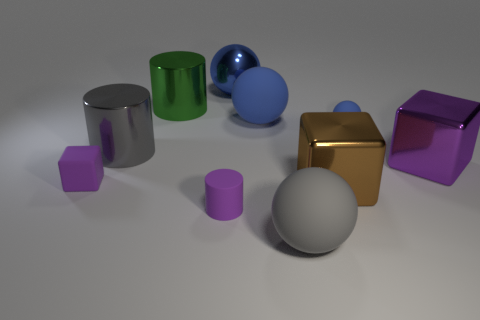Subtract all purple metal blocks. How many blocks are left? 2 Subtract all brown blocks. How many blue balls are left? 3 Subtract all gray spheres. How many spheres are left? 3 Subtract all cubes. How many objects are left? 7 Add 6 yellow cylinders. How many yellow cylinders exist? 6 Subtract 0 cyan blocks. How many objects are left? 10 Subtract all yellow spheres. Subtract all red cylinders. How many spheres are left? 4 Subtract all small cyan metal cylinders. Subtract all big gray shiny things. How many objects are left? 9 Add 8 gray rubber balls. How many gray rubber balls are left? 9 